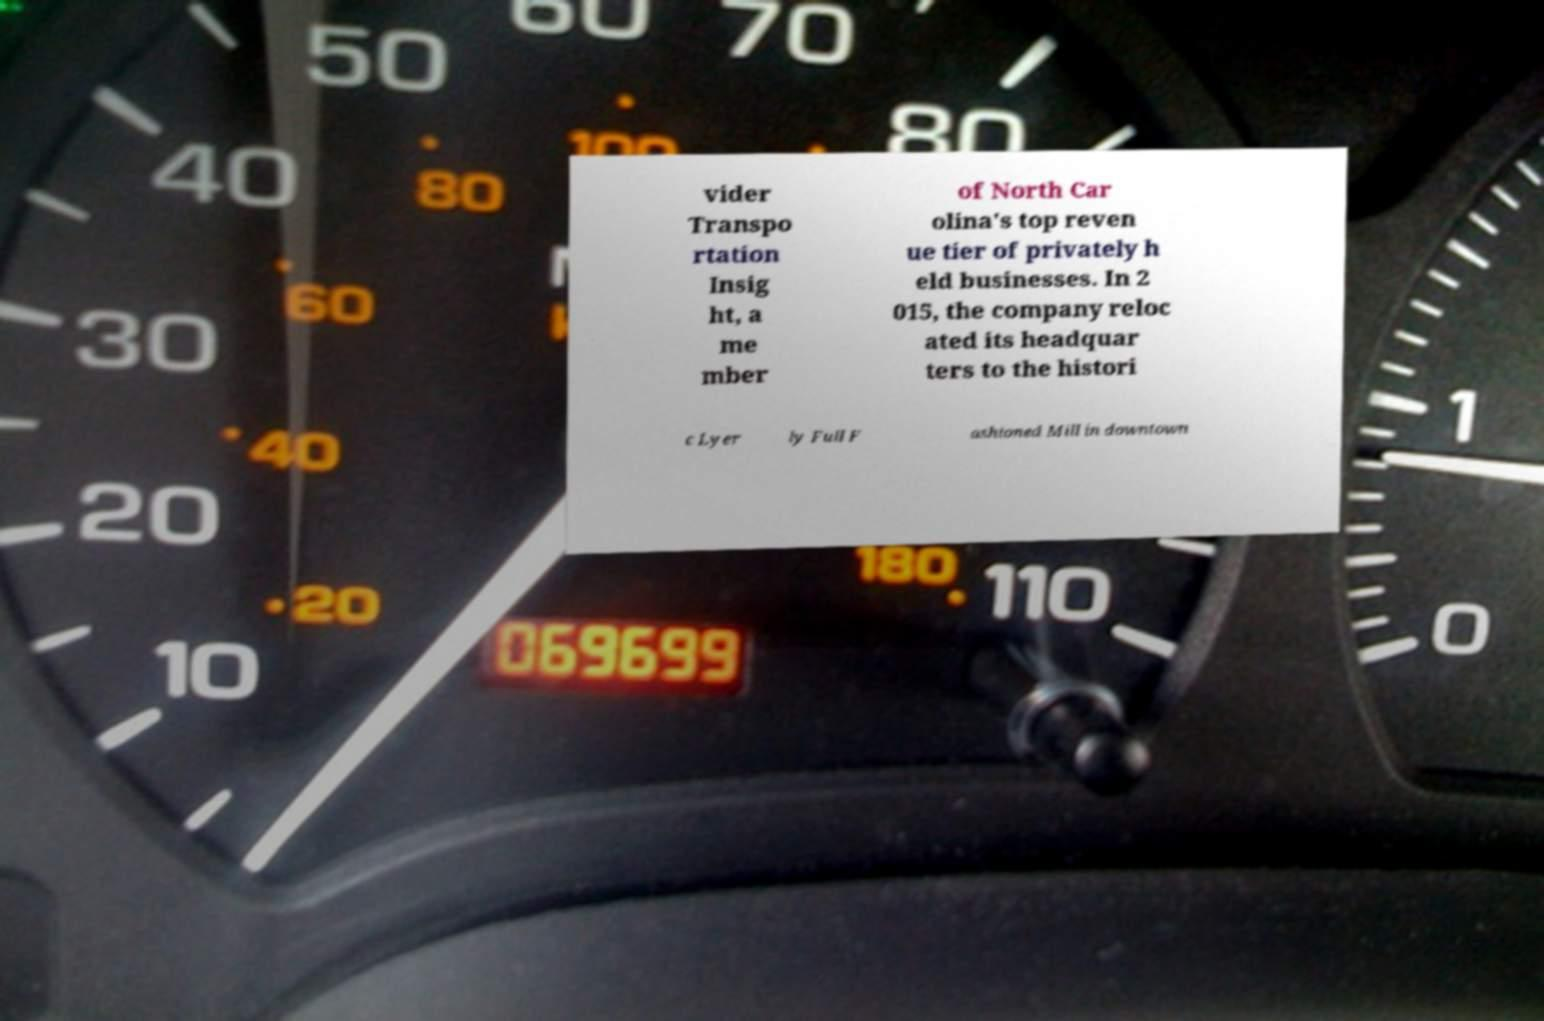What messages or text are displayed in this image? I need them in a readable, typed format. vider Transpo rtation Insig ht, a me mber of North Car olina's top reven ue tier of privately h eld businesses. In 2 015, the company reloc ated its headquar ters to the histori c Lyer ly Full F ashioned Mill in downtown 